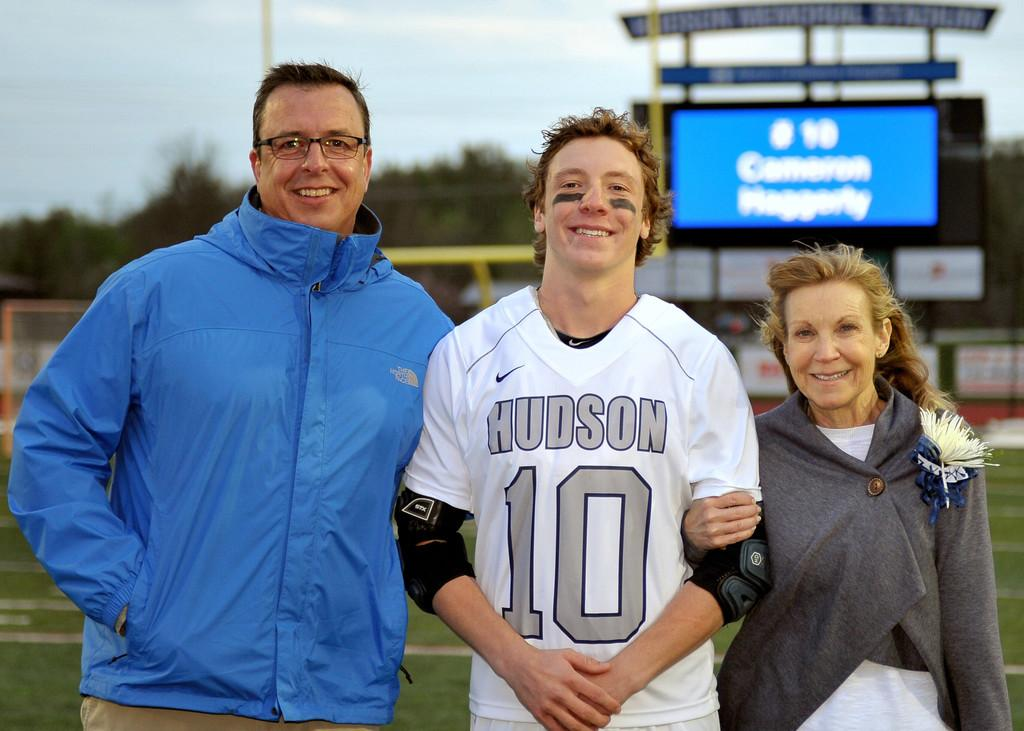Provide a one-sentence caption for the provided image. A player from the Hudson football team poses with a man and a woman. 